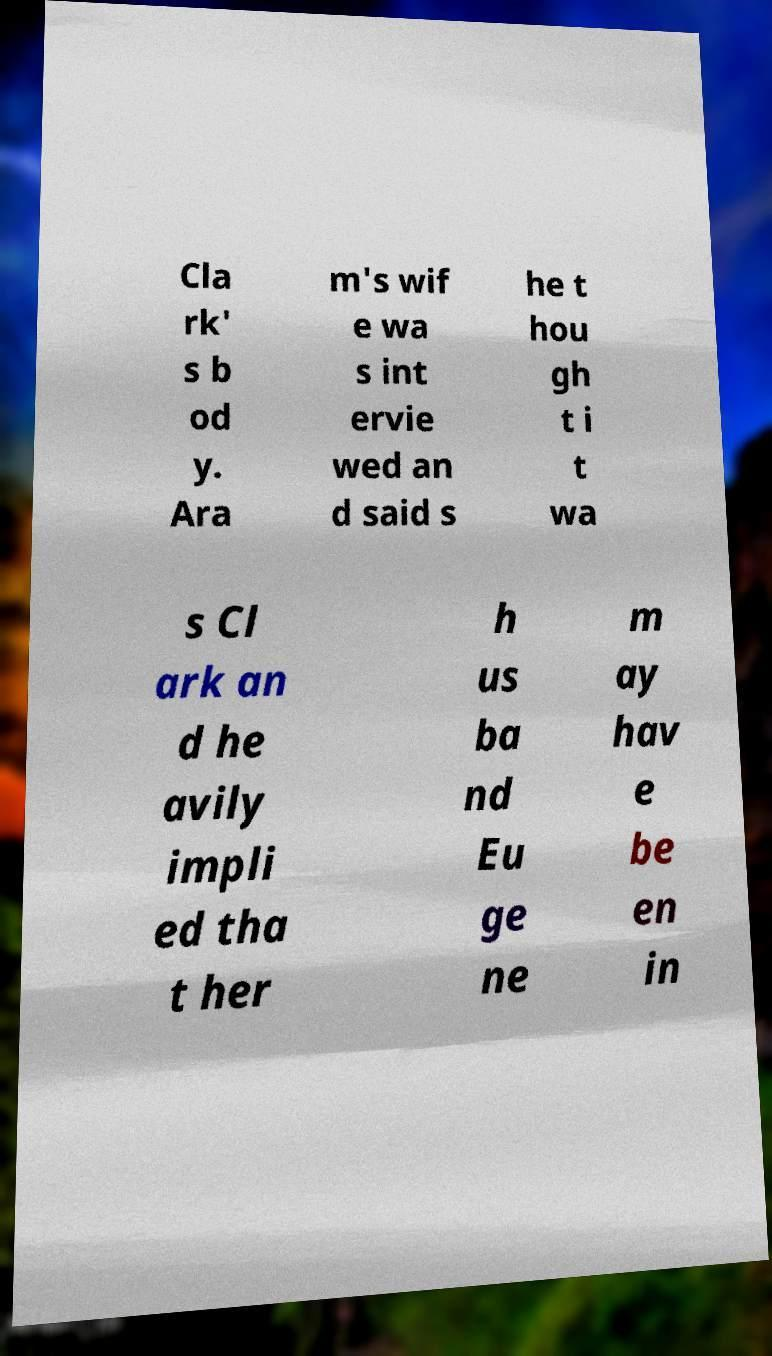Can you read and provide the text displayed in the image?This photo seems to have some interesting text. Can you extract and type it out for me? Cla rk' s b od y. Ara m's wif e wa s int ervie wed an d said s he t hou gh t i t wa s Cl ark an d he avily impli ed tha t her h us ba nd Eu ge ne m ay hav e be en in 